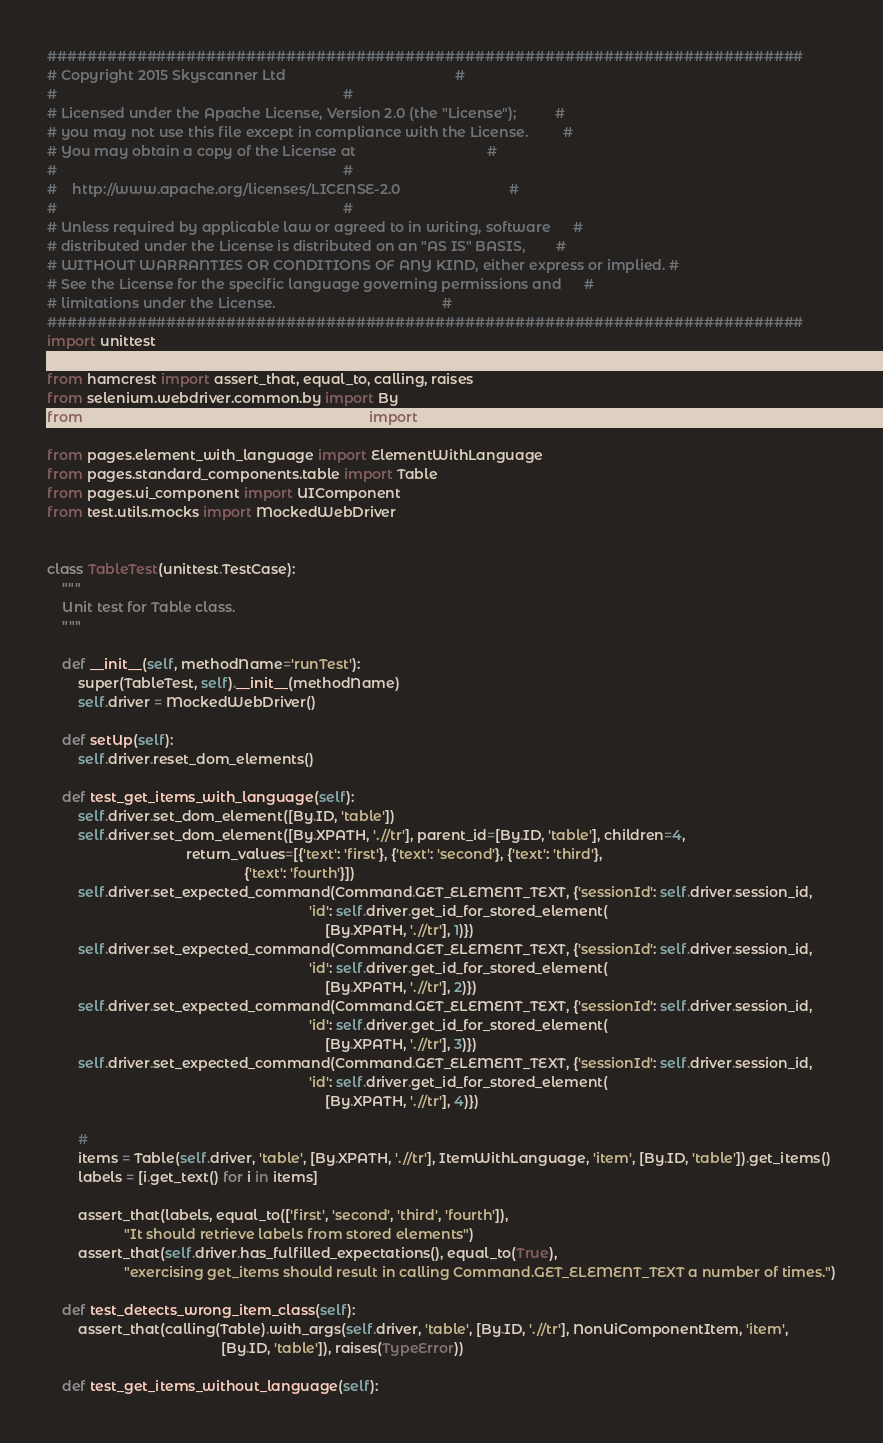Convert code to text. <code><loc_0><loc_0><loc_500><loc_500><_Python_>############################################################################
# Copyright 2015 Skyscanner Ltd                                            #
#                                                                          #
# Licensed under the Apache License, Version 2.0 (the "License");          #
# you may not use this file except in compliance with the License.         #
# You may obtain a copy of the License at                                  #
#                                                                          #
#    http://www.apache.org/licenses/LICENSE-2.0                            #
#                                                                          #
# Unless required by applicable law or agreed to in writing, software      #
# distributed under the License is distributed on an "AS IS" BASIS,        #
# WITHOUT WARRANTIES OR CONDITIONS OF ANY KIND, either express or implied. #
# See the License for the specific language governing permissions and      #
# limitations under the License.                                           #
############################################################################
import unittest

from hamcrest import assert_that, equal_to, calling, raises
from selenium.webdriver.common.by import By
from selenium.webdriver.remote.command import Command

from pages.element_with_language import ElementWithLanguage
from pages.standard_components.table import Table
from pages.ui_component import UIComponent
from test.utils.mocks import MockedWebDriver


class TableTest(unittest.TestCase):
    """
    Unit test for Table class.
    """

    def __init__(self, methodName='runTest'):
        super(TableTest, self).__init__(methodName)
        self.driver = MockedWebDriver()

    def setUp(self):
        self.driver.reset_dom_elements()

    def test_get_items_with_language(self):
        self.driver.set_dom_element([By.ID, 'table'])
        self.driver.set_dom_element([By.XPATH, './/tr'], parent_id=[By.ID, 'table'], children=4,
                                    return_values=[{'text': 'first'}, {'text': 'second'}, {'text': 'third'},
                                                   {'text': 'fourth'}])
        self.driver.set_expected_command(Command.GET_ELEMENT_TEXT, {'sessionId': self.driver.session_id,
                                                                    'id': self.driver.get_id_for_stored_element(
                                                                        [By.XPATH, './/tr'], 1)})
        self.driver.set_expected_command(Command.GET_ELEMENT_TEXT, {'sessionId': self.driver.session_id,
                                                                    'id': self.driver.get_id_for_stored_element(
                                                                        [By.XPATH, './/tr'], 2)})
        self.driver.set_expected_command(Command.GET_ELEMENT_TEXT, {'sessionId': self.driver.session_id,
                                                                    'id': self.driver.get_id_for_stored_element(
                                                                        [By.XPATH, './/tr'], 3)})
        self.driver.set_expected_command(Command.GET_ELEMENT_TEXT, {'sessionId': self.driver.session_id,
                                                                    'id': self.driver.get_id_for_stored_element(
                                                                        [By.XPATH, './/tr'], 4)})

        #
        items = Table(self.driver, 'table', [By.XPATH, './/tr'], ItemWithLanguage, 'item', [By.ID, 'table']).get_items()
        labels = [i.get_text() for i in items]

        assert_that(labels, equal_to(['first', 'second', 'third', 'fourth']),
                    "It should retrieve labels from stored elements")
        assert_that(self.driver.has_fulfilled_expectations(), equal_to(True),
                    "exercising get_items should result in calling Command.GET_ELEMENT_TEXT a number of times.")

    def test_detects_wrong_item_class(self):
        assert_that(calling(Table).with_args(self.driver, 'table', [By.ID, './/tr'], NonUiComponentItem, 'item',
                                             [By.ID, 'table']), raises(TypeError))

    def test_get_items_without_language(self):</code> 